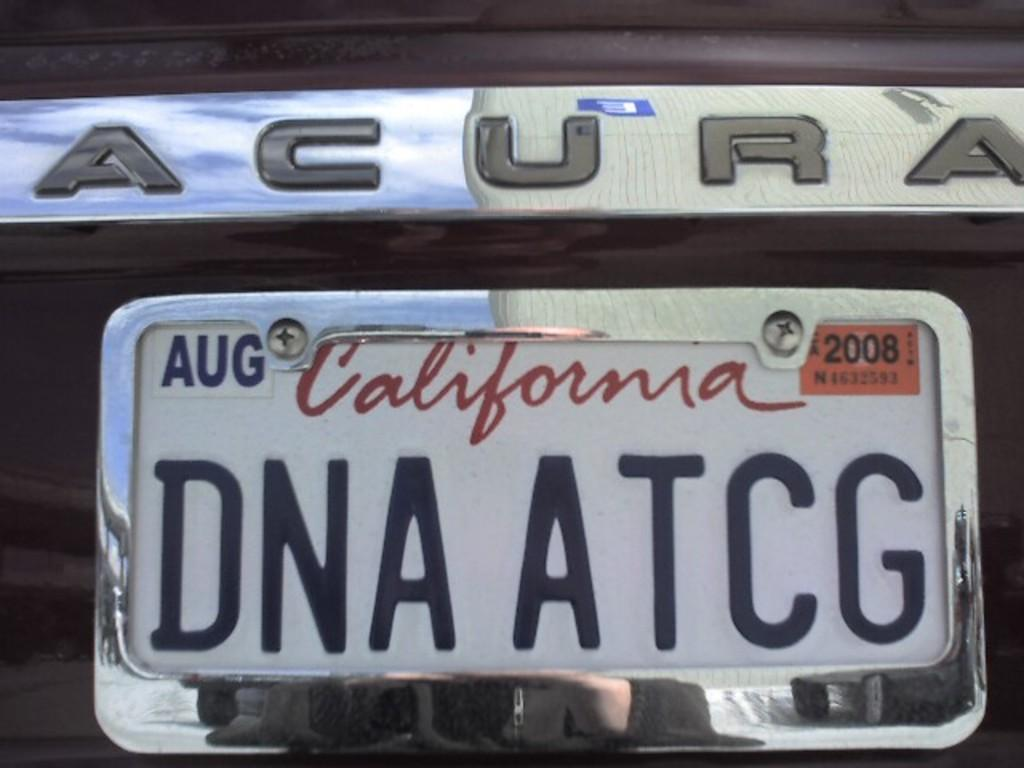<image>
Offer a succinct explanation of the picture presented. The California tag on the Acura expires in Aug 2008 